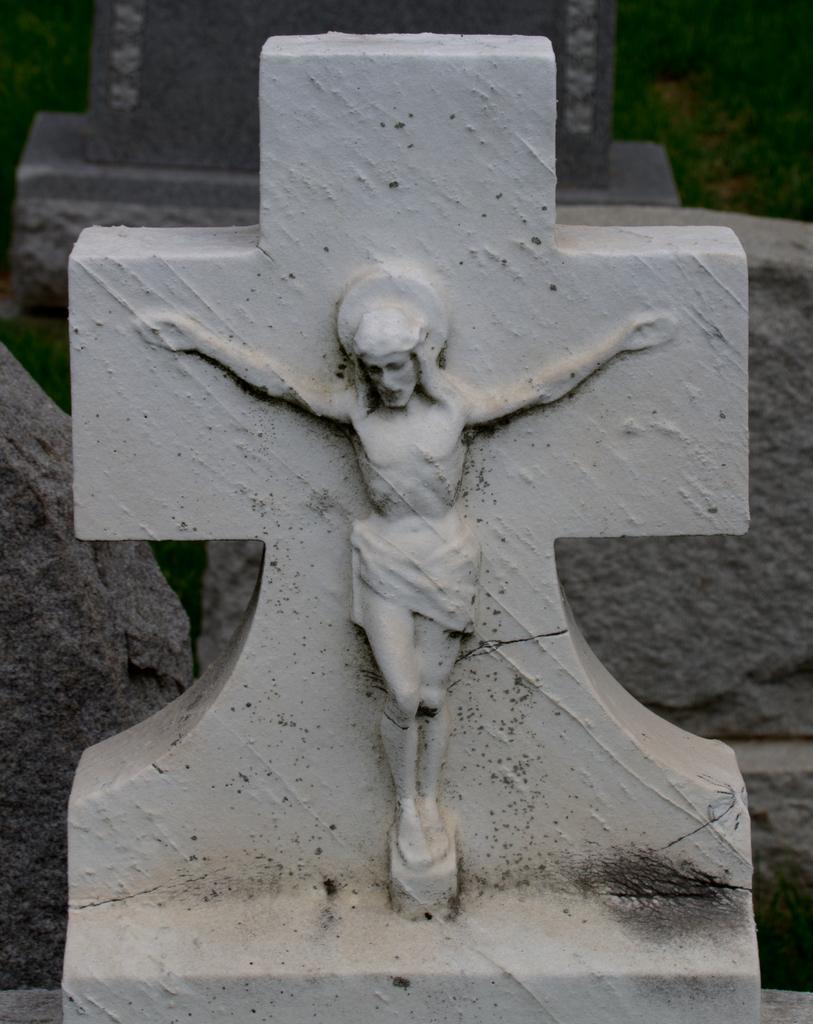Please provide a concise description of this image. In this image we can able to Jesus sculpture on cross symbol, behind with it we can see some rocks. 